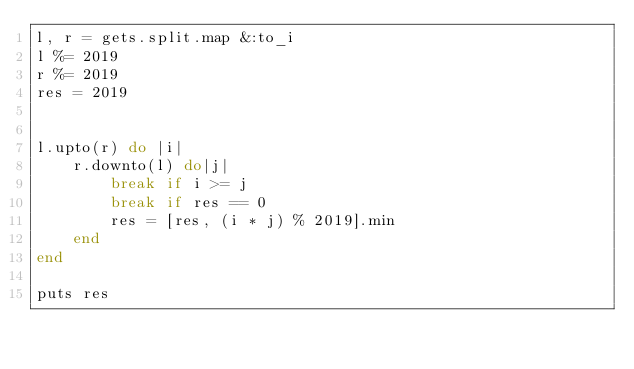Convert code to text. <code><loc_0><loc_0><loc_500><loc_500><_Ruby_>l, r = gets.split.map &:to_i
l %= 2019
r %= 2019
res = 2019


l.upto(r) do |i| 
    r.downto(l) do|j|
        break if i >= j
        break if res == 0
        res = [res, (i * j) % 2019].min
    end
end

puts res</code> 